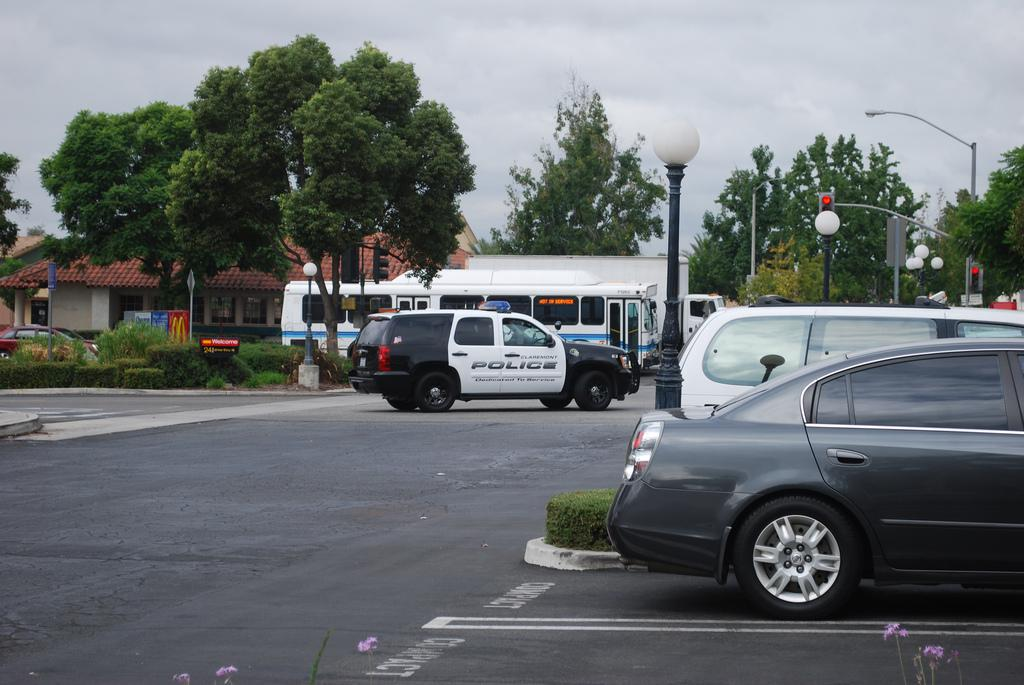Question: when will the police car get to the street?
Choices:
A. In a flash.
B. Very soon.
C. In five minutes.
D. After they turn the corner.
Answer with the letter. Answer: B Question: who is in the black and white car?
Choices:
A. A detective.
B. A police person.
C. A dog catcher.
D. A coroner.
Answer with the letter. Answer: B Question: where is the police car parked?
Choices:
A. Outside the station.
B. It is moving towards the street, not parked.
C. Outside the school.
D. Outside the hotel.
Answer with the letter. Answer: B Question: what number of colors does the police car have?
Choices:
A. Three.
B. Two.
C. Four.
D. Five.
Answer with the letter. Answer: B Question: why are the lights on the lamp posts in the parking lot off?
Choices:
A. They are not switched on.
B. They go on at night.
C. They are spoiled.
D. It daytime.
Answer with the letter. Answer: B Question: what color is the roof of the building behind the bus?
Choices:
A. Reddish.
B. Red.
C. Dark red.
D. Maroon.
Answer with the letter. Answer: A Question: what can you see behind the police suv?
Choices:
A. A taxi.
B. A bus.
C. An ambulance.
D. A firetruck.
Answer with the letter. Answer: B Question: what food chain is behind the bus?
Choices:
A. Mcdonalds.
B. Burger King.
C. Wendy's.
D. Arby's.
Answer with the letter. Answer: A Question: what does the sky look like?
Choices:
A. Bright and sunny.
B. Black and stormy.
C. Gray and cloudy.
D. Cloudy and white.
Answer with the letter. Answer: C Question: how do you know where the streets are?
Choices:
A. Street signs.
B. The streets have markings.
C. Stop lights.
D. Stop signs.
Answer with the letter. Answer: B Question: what is parked in the parking lot?
Choices:
A. Trucks.
B. Bikes.
C. Motorcycles.
D. Cars.
Answer with the letter. Answer: D Question: how many full trees are shown on the left?
Choices:
A. 6.
B. 4.
C. 5.
D. 3.
Answer with the letter. Answer: D Question: what is black and white?
Choices:
A. A truck.
B. A bus.
C. A police vehicle.
D. A train.
Answer with the letter. Answer: C Question: what color is the road?
Choices:
A. Black.
B. Brown.
C. White.
D. Grey.
Answer with the letter. Answer: D Question: what are the parking spaces labeled?
Choices:
A. Handicapped.
B. Large.
C. "compact".
D. Medium.
Answer with the letter. Answer: C Question: how many parking spaces are empty?
Choices:
A. Three.
B. Four.
C. One.
D. Six.
Answer with the letter. Answer: C 